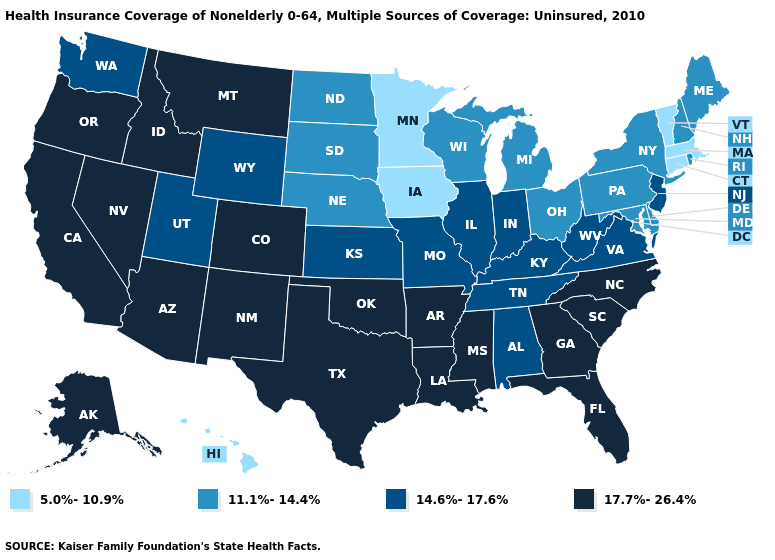Name the states that have a value in the range 11.1%-14.4%?
Write a very short answer. Delaware, Maine, Maryland, Michigan, Nebraska, New Hampshire, New York, North Dakota, Ohio, Pennsylvania, Rhode Island, South Dakota, Wisconsin. Name the states that have a value in the range 17.7%-26.4%?
Give a very brief answer. Alaska, Arizona, Arkansas, California, Colorado, Florida, Georgia, Idaho, Louisiana, Mississippi, Montana, Nevada, New Mexico, North Carolina, Oklahoma, Oregon, South Carolina, Texas. Among the states that border Oregon , does Nevada have the lowest value?
Write a very short answer. No. What is the lowest value in states that border Oklahoma?
Give a very brief answer. 14.6%-17.6%. Name the states that have a value in the range 5.0%-10.9%?
Short answer required. Connecticut, Hawaii, Iowa, Massachusetts, Minnesota, Vermont. What is the highest value in the USA?
Concise answer only. 17.7%-26.4%. How many symbols are there in the legend?
Answer briefly. 4. Which states have the lowest value in the Northeast?
Concise answer only. Connecticut, Massachusetts, Vermont. Does Maryland have a lower value than Tennessee?
Keep it brief. Yes. What is the value of New Mexico?
Be succinct. 17.7%-26.4%. Name the states that have a value in the range 14.6%-17.6%?
Quick response, please. Alabama, Illinois, Indiana, Kansas, Kentucky, Missouri, New Jersey, Tennessee, Utah, Virginia, Washington, West Virginia, Wyoming. Name the states that have a value in the range 17.7%-26.4%?
Concise answer only. Alaska, Arizona, Arkansas, California, Colorado, Florida, Georgia, Idaho, Louisiana, Mississippi, Montana, Nevada, New Mexico, North Carolina, Oklahoma, Oregon, South Carolina, Texas. How many symbols are there in the legend?
Keep it brief. 4. What is the lowest value in the USA?
Write a very short answer. 5.0%-10.9%. Which states have the lowest value in the Northeast?
Write a very short answer. Connecticut, Massachusetts, Vermont. 